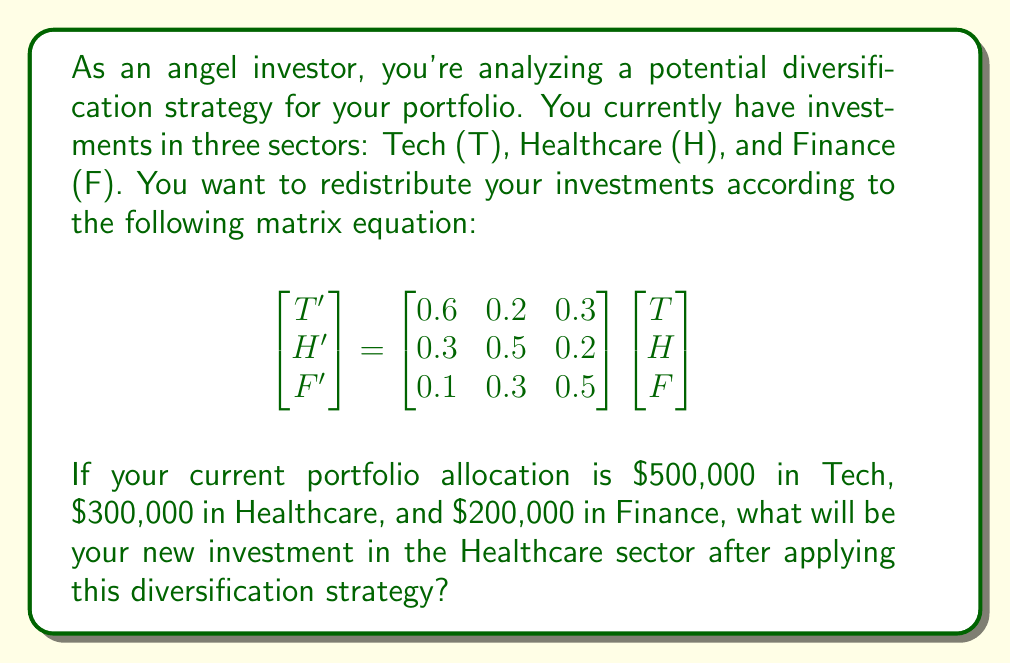Can you solve this math problem? Let's approach this step-by-step:

1) First, we need to set up our initial investment vector:
   $$\begin{bmatrix} T \\ H \\ F \end{bmatrix} = \begin{bmatrix} 500,000 \\ 300,000 \\ 200,000 \end{bmatrix}$$

2) Now, we can perform the matrix multiplication:
   $$\begin{bmatrix} T' \\ H' \\ F' \end{bmatrix} = \begin{bmatrix} 0.6 & 0.2 & 0.3 \\ 0.3 & 0.5 & 0.2 \\ 0.1 & 0.3 & 0.5 \end{bmatrix} \begin{bmatrix} 500,000 \\ 300,000 \\ 200,000 \end{bmatrix}$$

3) Let's focus on the second row, which corresponds to the new Healthcare investment (H'):
   $$H' = 0.3(500,000) + 0.5(300,000) + 0.2(200,000)$$

4) Now we can calculate:
   $$H' = 150,000 + 150,000 + 40,000 = 340,000$$

Therefore, the new investment in the Healthcare sector will be $\$340,000.
Answer: $\$340,000 